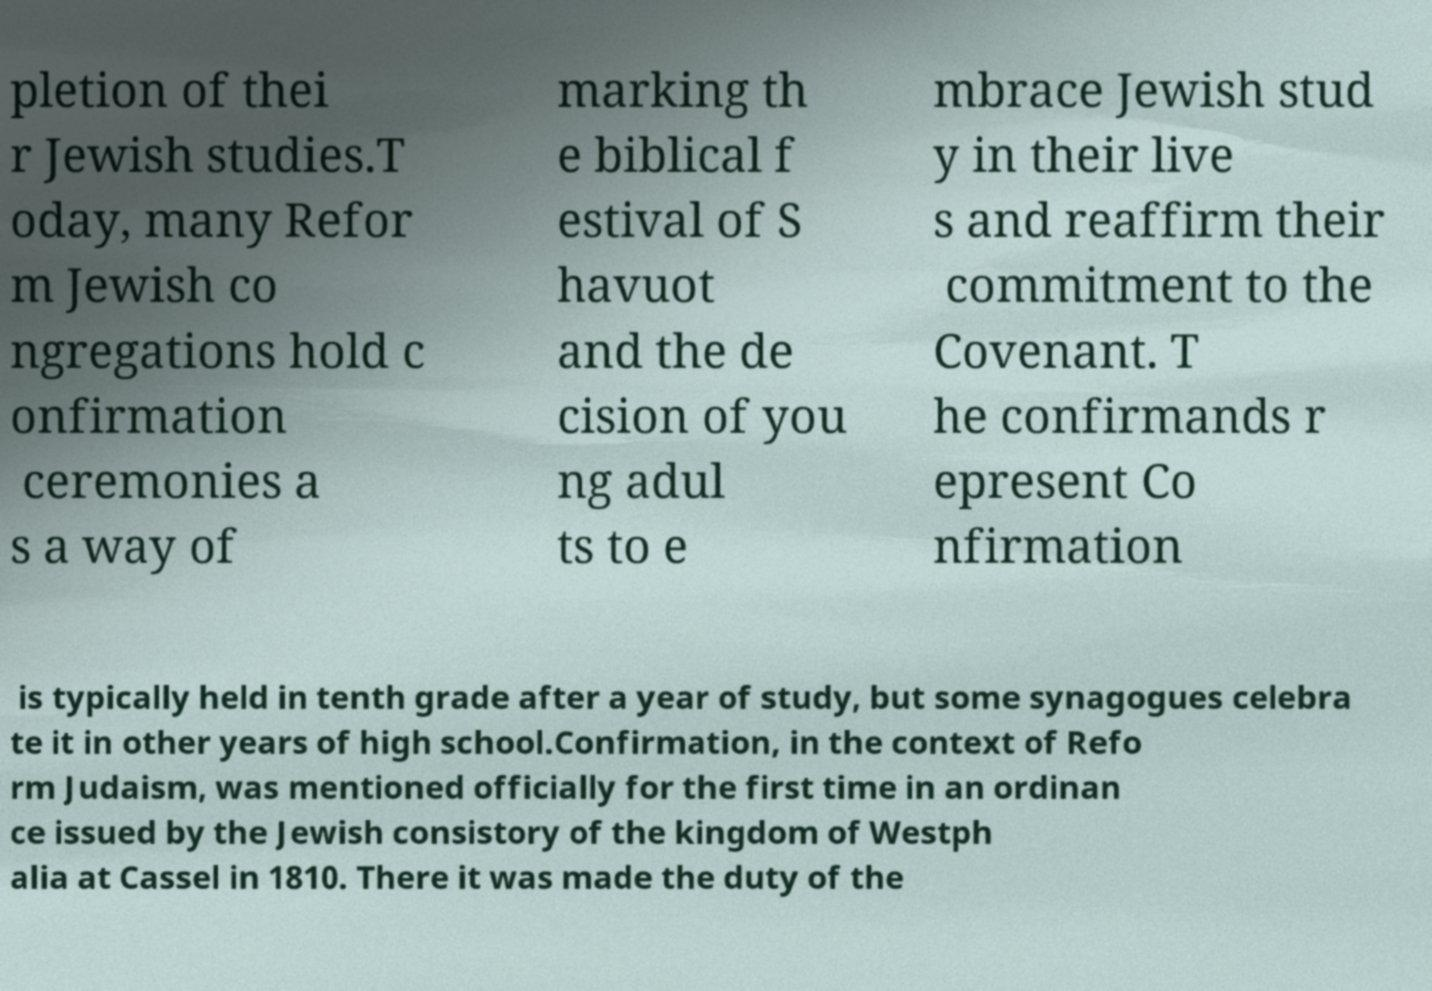Can you read and provide the text displayed in the image?This photo seems to have some interesting text. Can you extract and type it out for me? pletion of thei r Jewish studies.T oday, many Refor m Jewish co ngregations hold c onfirmation ceremonies a s a way of marking th e biblical f estival of S havuot and the de cision of you ng adul ts to e mbrace Jewish stud y in their live s and reaffirm their commitment to the Covenant. T he confirmands r epresent Co nfirmation is typically held in tenth grade after a year of study, but some synagogues celebra te it in other years of high school.Confirmation, in the context of Refo rm Judaism, was mentioned officially for the first time in an ordinan ce issued by the Jewish consistory of the kingdom of Westph alia at Cassel in 1810. There it was made the duty of the 